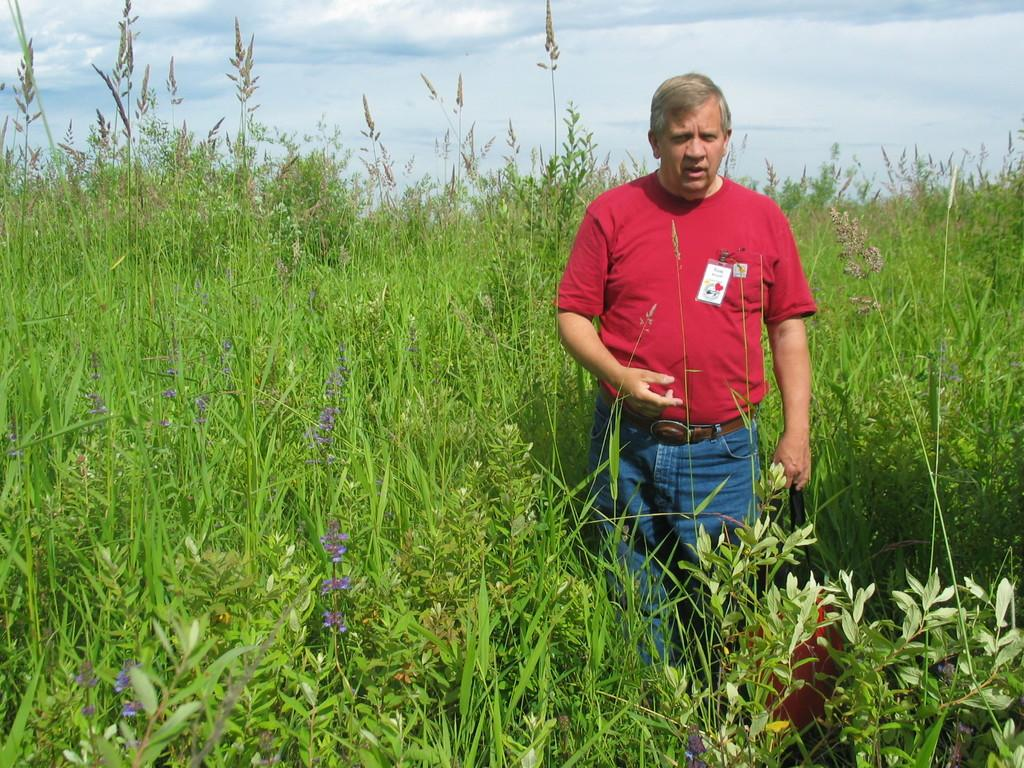Who or what is present in the image? There is a person in the image. What is the person wearing in the image? The person is wearing a tag in the image. What type of natural elements can be seen in the image? There are plants and clouds in the image. What type of bells can be heard ringing in the image? There are no bells present in the image, and therefore no sounds can be heard. 